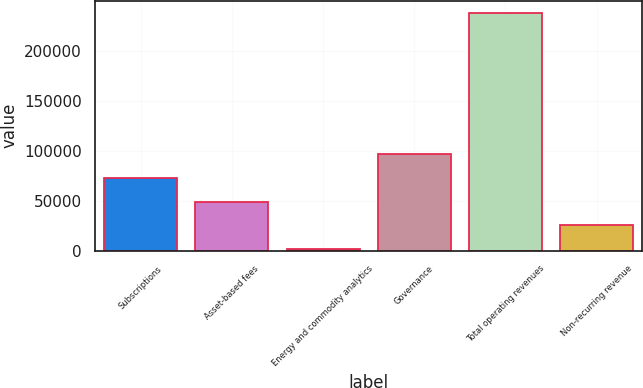Convert chart to OTSL. <chart><loc_0><loc_0><loc_500><loc_500><bar_chart><fcel>Subscriptions<fcel>Asset-based fees<fcel>Energy and commodity analytics<fcel>Governance<fcel>Total operating revenues<fcel>Non-recurring revenue<nl><fcel>72787.5<fcel>49180<fcel>1965<fcel>96395<fcel>238040<fcel>25572.5<nl></chart> 